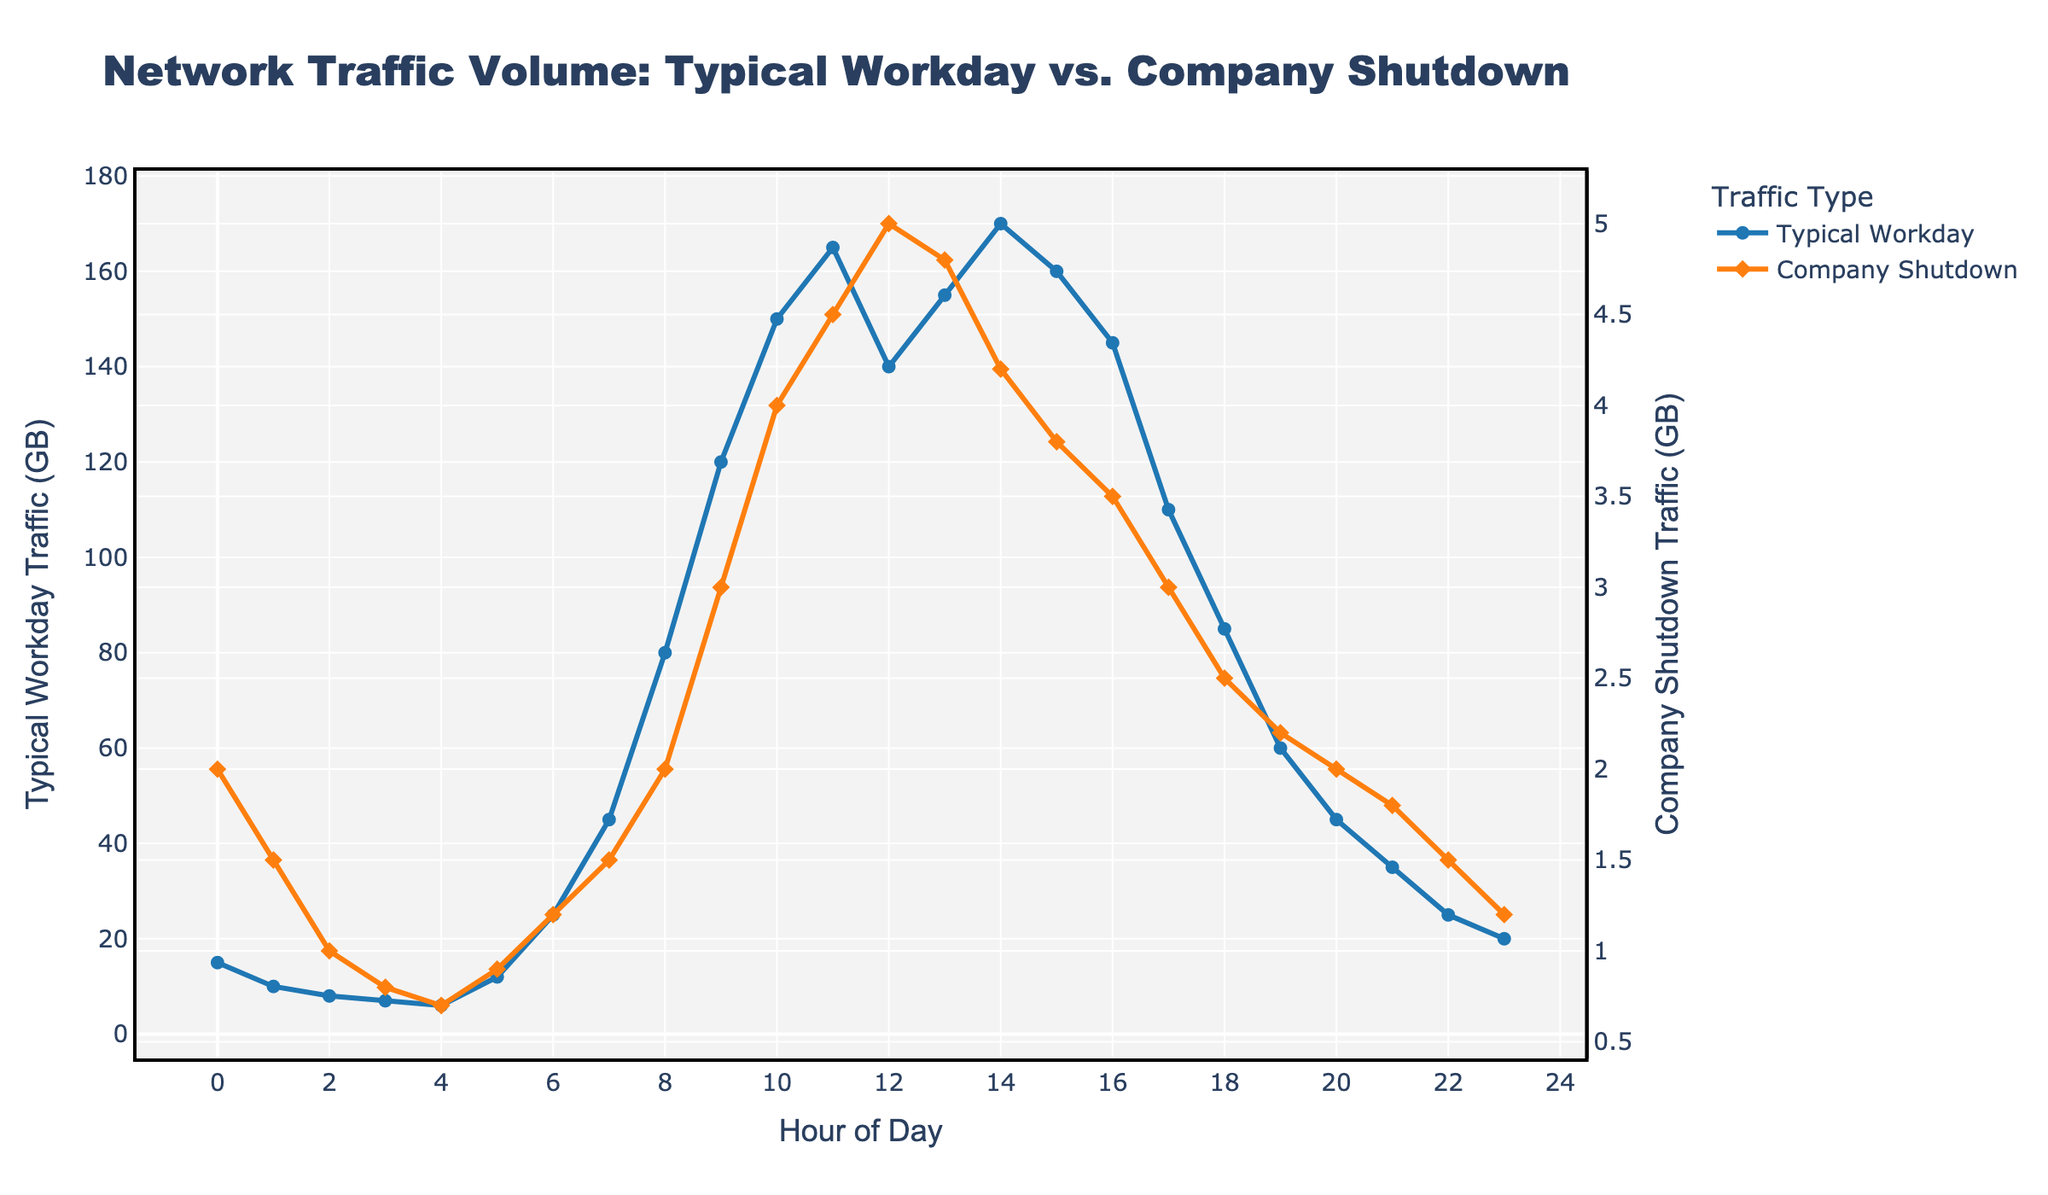What time does the network traffic peak during a typical workday? By looking at the higher points of the line representing the typical workday and noting the corresponding hour on the x-axis, the peak traffic volume can be observed.
Answer: 14:00 What is the approximate network traffic at 10 AM during a typical workday? Locate the point on the typical workday line that corresponds to 10 AM on the x-axis and read the traffic value from the y-axis.
Answer: 150 GB What is the difference in network traffic between a typical workday and a company shutdown at 11 AM? Find the network traffic values for 11 AM for both a typical workday and a company shutdown, then subtract the shutdown traffic from the typical workday traffic. (165 GB - 4.5 GB)
Answer: 160.5 GB How does the network traffic at 8 PM compare between a typical workday and a company shutdown? Compare the traffic values at 8 PM on both lines. The typical workday line value is higher than the company shutdown line value.
Answer: Typical workday traffic is higher When is the lowest network traffic observed during a company shutdown? Locate the lowest point on the company shutdown line and note the corresponding hour.
Answer: 4:00 AM What is the sum of the network traffic at 3 AM for both a typical workday and a company shutdown? Find the traffic values at 3 AM for both lines and add them together. (7 GB + 0.8 GB)
Answer: 7.8 GB What are the general trends in network traffic for a typical workday compared to a company-wide shutdown? Observe both lines - the typical workday shows increasing traffic during the day and decreasing during the evening, whereas the company shutdown line remains relatively flat with minimal fluctuations.
Answer: Typical workday increases and decreases systematically; shutdown remains flat At what hour of the day does the network traffic start to increase rapidly during a typical workday? Look for where the slope of the typical workday line becomes steep and starts to increase significantly.
Answer: 6:00 AM What is the visual difference between the markers used for typical workday traffic and company shutdown traffic? The typical workday traffic line uses circular markers, while the company shutdown traffic line uses diamond-shaped markers.
Answer: Circles for workday, diamonds for shutdown 